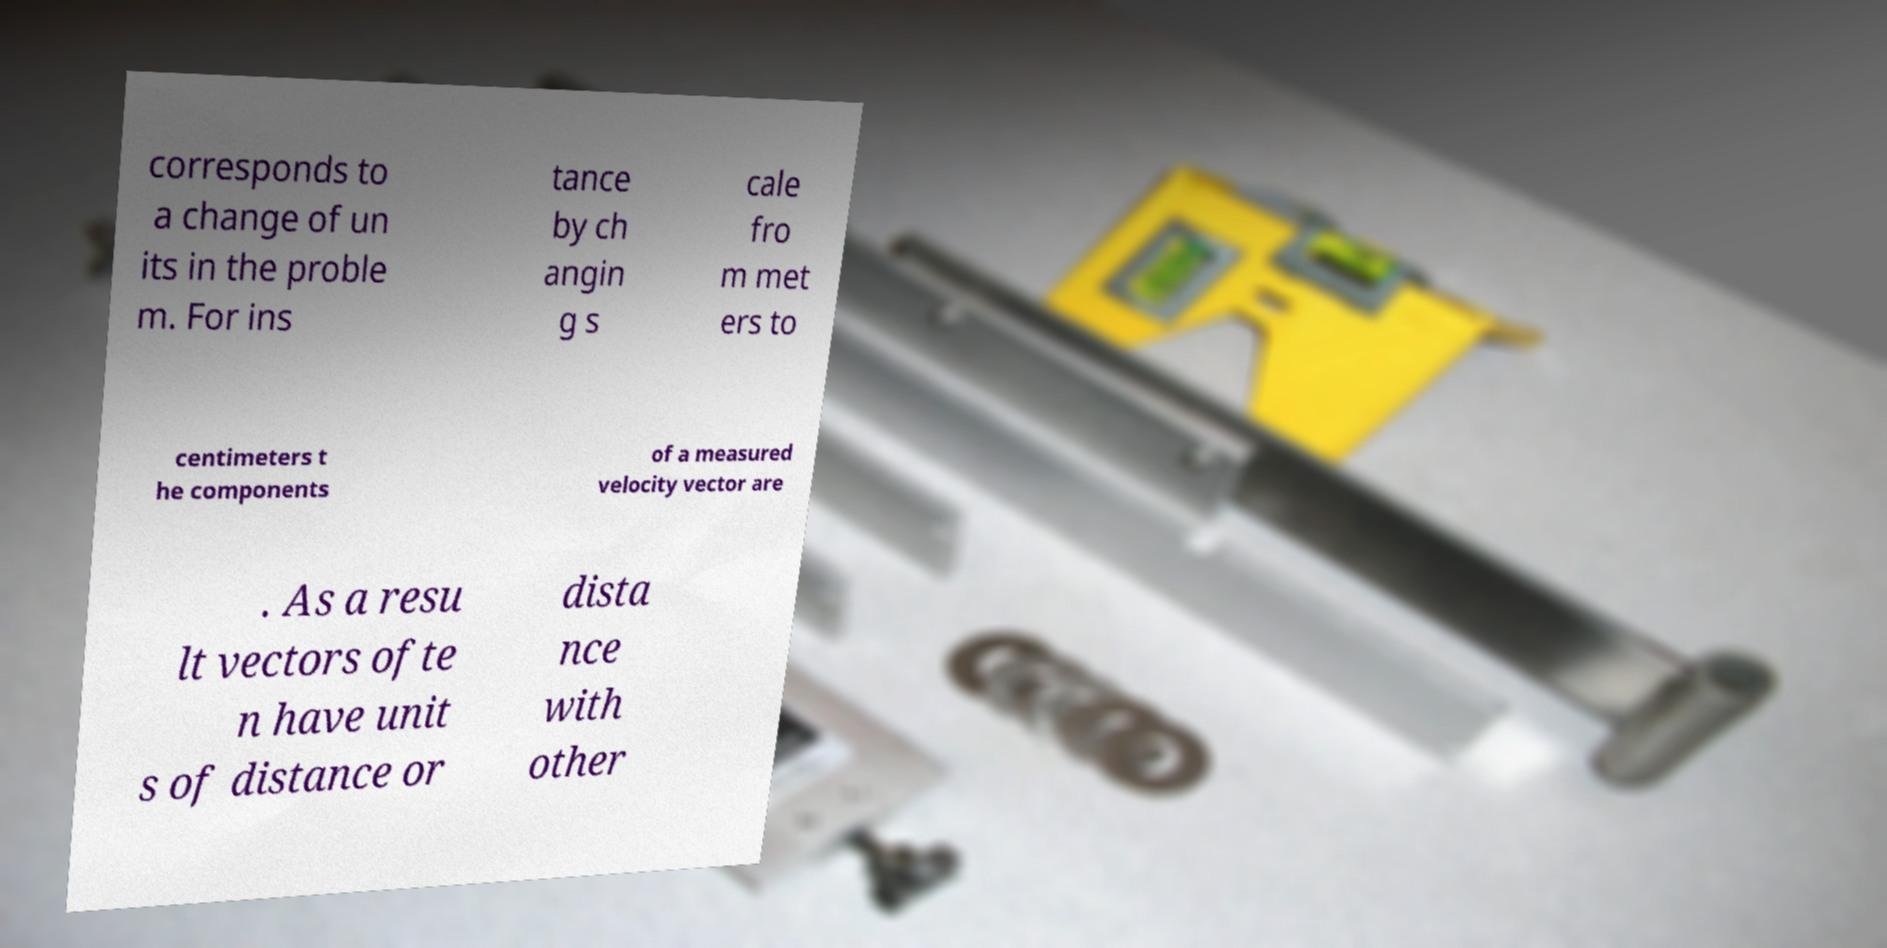Can you accurately transcribe the text from the provided image for me? corresponds to a change of un its in the proble m. For ins tance by ch angin g s cale fro m met ers to centimeters t he components of a measured velocity vector are . As a resu lt vectors ofte n have unit s of distance or dista nce with other 